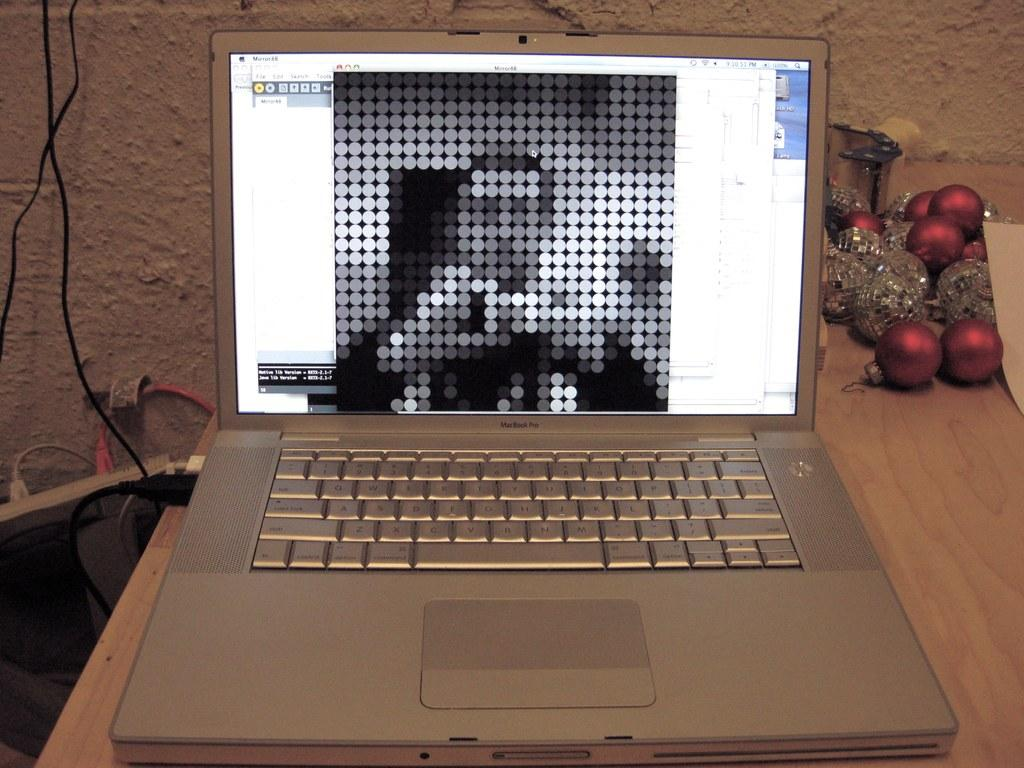What electronic device is visible in the image? There is a laptop in the image. Where is the laptop located? The laptop is on a table. Is there any connection to the laptop in the image? Yes, a data cable is connected to the laptop. What can be seen in the background of the image? There is a wall in the background of the image. What is the temperature of the laptop in the image? The temperature of the laptop cannot be determined from the image alone. 